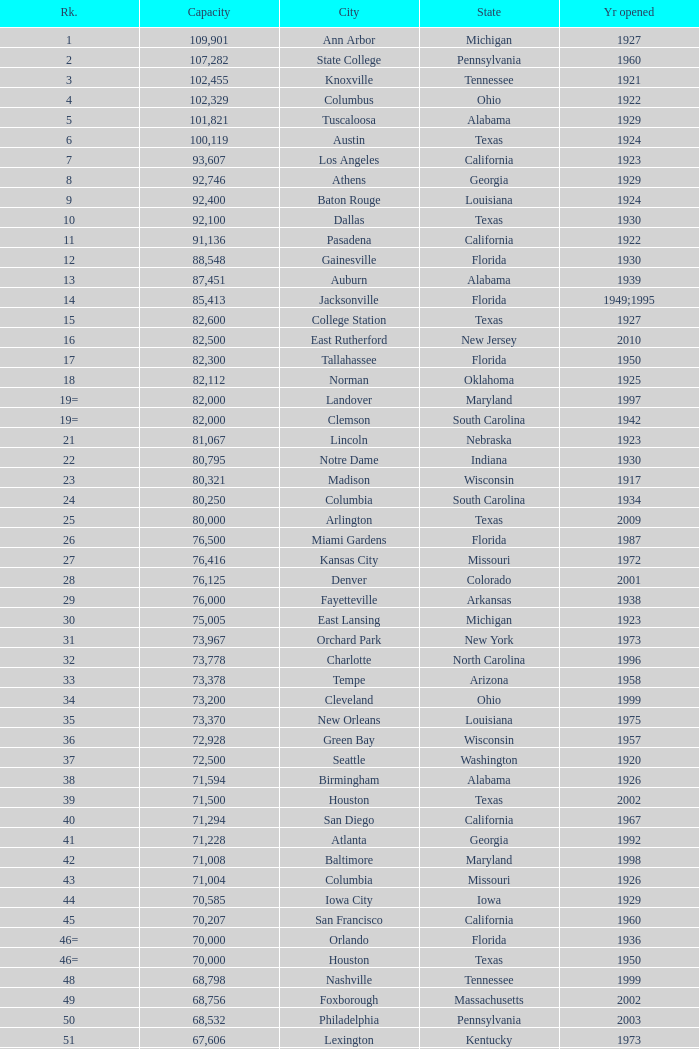What was the year opened for North Carolina with a smaller than 21,500 capacity? 1926.0. 